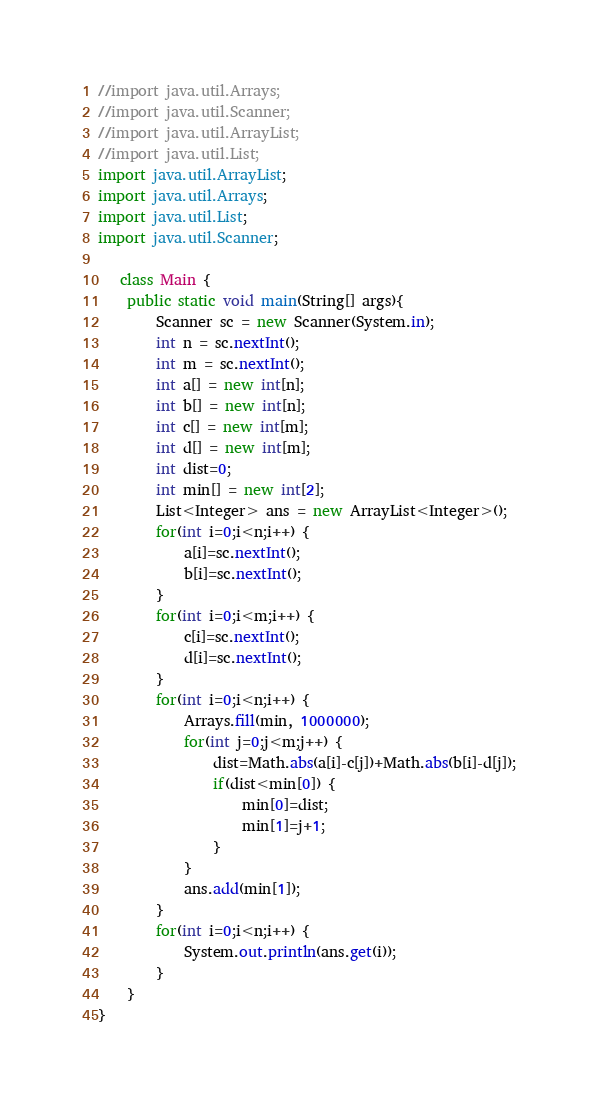<code> <loc_0><loc_0><loc_500><loc_500><_Java_>//import java.util.Arrays;
//import java.util.Scanner;
//import java.util.ArrayList;
//import java.util.List;
import java.util.ArrayList;
import java.util.Arrays;
import java.util.List;
import java.util.Scanner;

   class Main {
    public static void main(String[] args){
    	Scanner sc = new Scanner(System.in);
    	int n = sc.nextInt();
    	int m = sc.nextInt();
    	int a[] = new int[n];
    	int b[] = new int[n];
    	int c[] = new int[m];
    	int d[] = new int[m];
    	int dist=0;
    	int min[] = new int[2];
    	List<Integer> ans = new ArrayList<Integer>();
    	for(int i=0;i<n;i++) {
    		a[i]=sc.nextInt();
    		b[i]=sc.nextInt();
    	}
    	for(int i=0;i<m;i++) {
    		c[i]=sc.nextInt();
    		d[i]=sc.nextInt();
    	}
    	for(int i=0;i<n;i++) {
    		Arrays.fill(min, 1000000);
    		for(int j=0;j<m;j++) {
    			dist=Math.abs(a[i]-c[j])+Math.abs(b[i]-d[j]);
    			if(dist<min[0]) {
    				min[0]=dist;
    				min[1]=j+1;
    			}
    		}
    		ans.add(min[1]);
    	}
    	for(int i=0;i<n;i++) {
    		System.out.println(ans.get(i));
    	}
    }
}</code> 